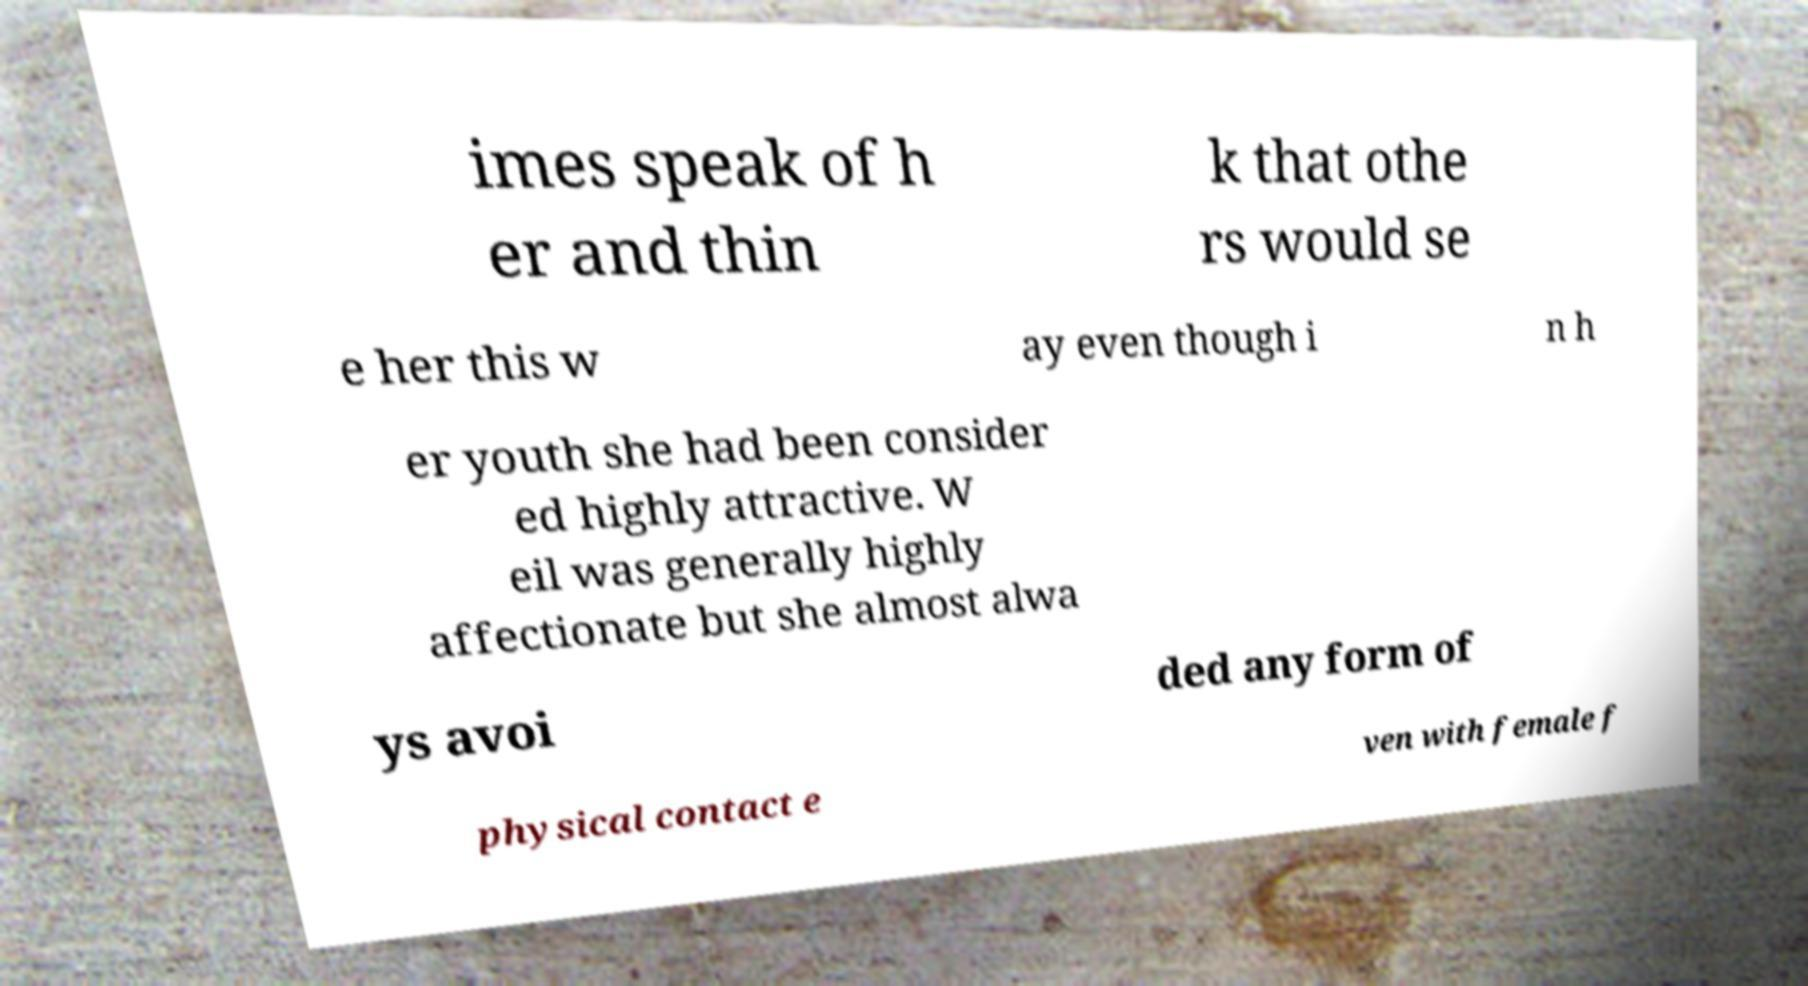Could you assist in decoding the text presented in this image and type it out clearly? imes speak of h er and thin k that othe rs would se e her this w ay even though i n h er youth she had been consider ed highly attractive. W eil was generally highly affectionate but she almost alwa ys avoi ded any form of physical contact e ven with female f 